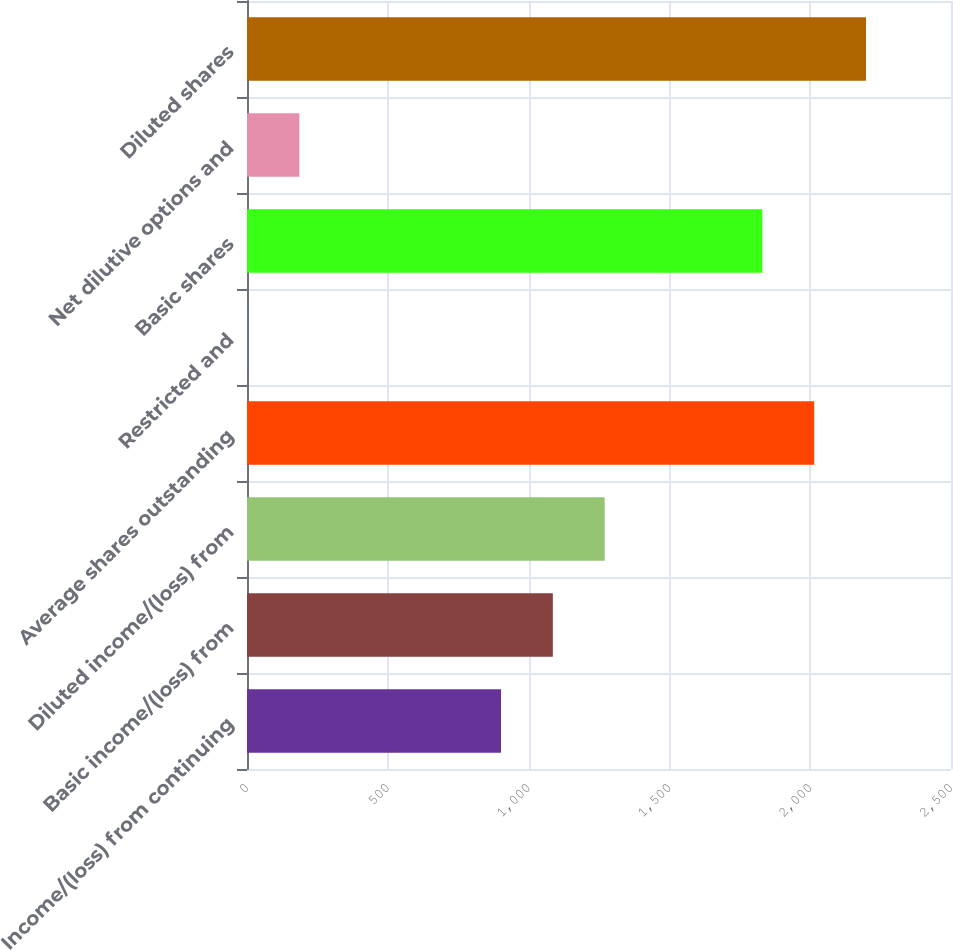Convert chart to OTSL. <chart><loc_0><loc_0><loc_500><loc_500><bar_chart><fcel>Income/(loss) from continuing<fcel>Basic income/(loss) from<fcel>Diluted income/(loss) from<fcel>Average shares outstanding<fcel>Restricted and<fcel>Basic shares<fcel>Net dilutive options and<fcel>Diluted shares<nl><fcel>902<fcel>1086.1<fcel>1270.2<fcel>2014.1<fcel>2<fcel>1830<fcel>186.1<fcel>2198.2<nl></chart> 